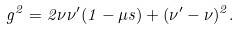Convert formula to latex. <formula><loc_0><loc_0><loc_500><loc_500>g ^ { 2 } = 2 \nu \nu ^ { \prime } ( 1 - \mu s ) + ( \nu ^ { \prime } - \nu ) ^ { 2 } .</formula> 